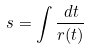<formula> <loc_0><loc_0><loc_500><loc_500>s = \int \frac { d t } { r ( t ) }</formula> 